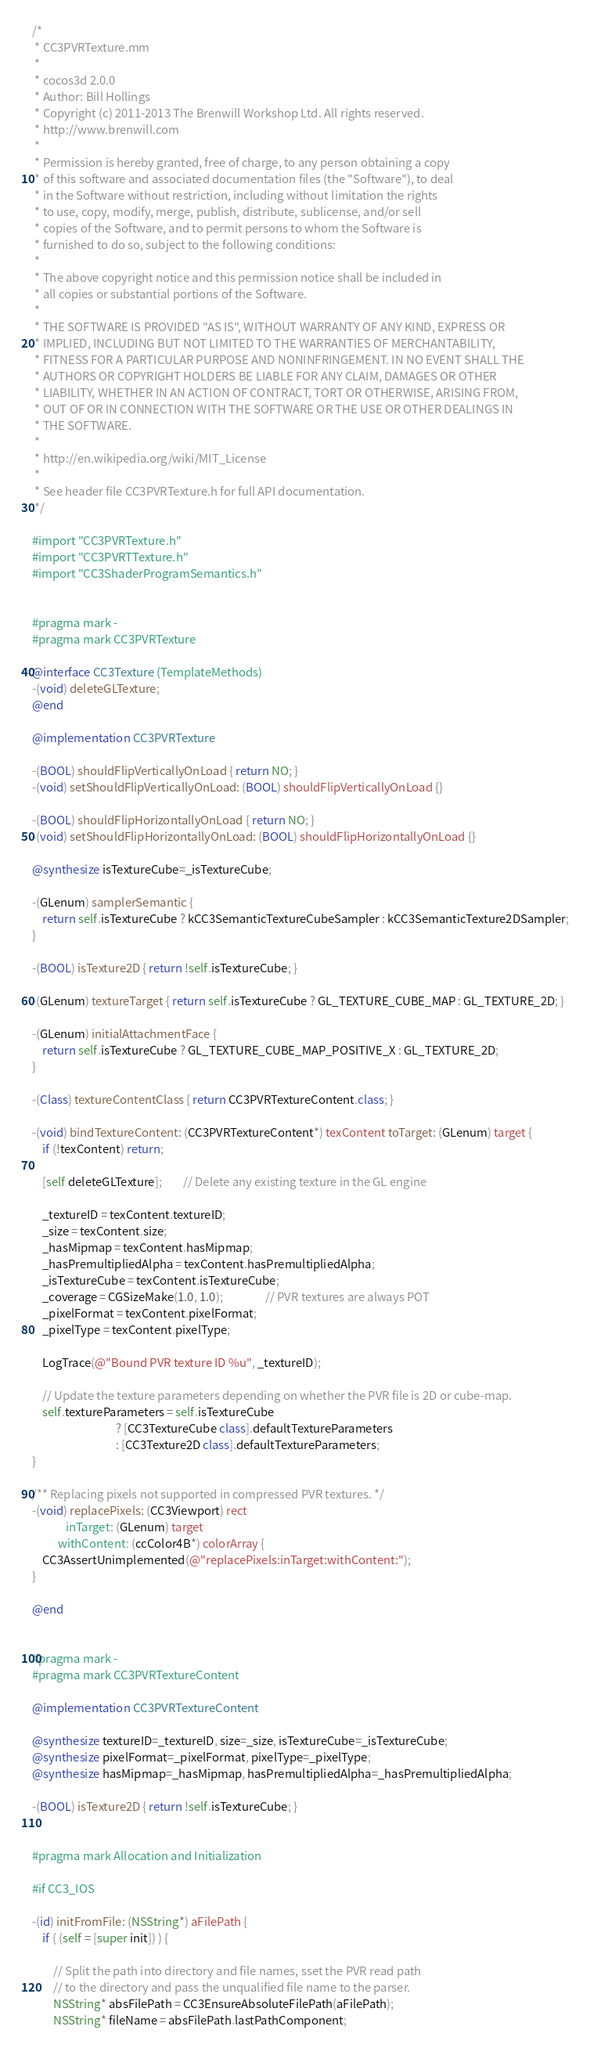Convert code to text. <code><loc_0><loc_0><loc_500><loc_500><_ObjectiveC_>/*
 * CC3PVRTexture.mm
 *
 * cocos3d 2.0.0
 * Author: Bill Hollings
 * Copyright (c) 2011-2013 The Brenwill Workshop Ltd. All rights reserved.
 * http://www.brenwill.com
 *
 * Permission is hereby granted, free of charge, to any person obtaining a copy
 * of this software and associated documentation files (the "Software"), to deal
 * in the Software without restriction, including without limitation the rights
 * to use, copy, modify, merge, publish, distribute, sublicense, and/or sell
 * copies of the Software, and to permit persons to whom the Software is
 * furnished to do so, subject to the following conditions:
 * 
 * The above copyright notice and this permission notice shall be included in
 * all copies or substantial portions of the Software.
 *
 * THE SOFTWARE IS PROVIDED "AS IS", WITHOUT WARRANTY OF ANY KIND, EXPRESS OR
 * IMPLIED, INCLUDING BUT NOT LIMITED TO THE WARRANTIES OF MERCHANTABILITY,
 * FITNESS FOR A PARTICULAR PURPOSE AND NONINFRINGEMENT. IN NO EVENT SHALL THE
 * AUTHORS OR COPYRIGHT HOLDERS BE LIABLE FOR ANY CLAIM, DAMAGES OR OTHER
 * LIABILITY, WHETHER IN AN ACTION OF CONTRACT, TORT OR OTHERWISE, ARISING FROM,
 * OUT OF OR IN CONNECTION WITH THE SOFTWARE OR THE USE OR OTHER DEALINGS IN
 * THE SOFTWARE.
 *
 * http://en.wikipedia.org/wiki/MIT_License
 * 
 * See header file CC3PVRTexture.h for full API documentation.
 */

#import "CC3PVRTexture.h"
#import "CC3PVRTTexture.h"
#import "CC3ShaderProgramSemantics.h"


#pragma mark -
#pragma mark CC3PVRTexture

@interface CC3Texture (TemplateMethods)
-(void) deleteGLTexture;
@end

@implementation CC3PVRTexture

-(BOOL) shouldFlipVerticallyOnLoad { return NO; }
-(void) setShouldFlipVerticallyOnLoad: (BOOL) shouldFlipVerticallyOnLoad {}

-(BOOL) shouldFlipHorizontallyOnLoad { return NO; }
-(void) setShouldFlipHorizontallyOnLoad: (BOOL) shouldFlipHorizontallyOnLoad {}

@synthesize isTextureCube=_isTextureCube;

-(GLenum) samplerSemantic {
	return self.isTextureCube ? kCC3SemanticTextureCubeSampler : kCC3SemanticTexture2DSampler;
}

-(BOOL) isTexture2D { return !self.isTextureCube; }

-(GLenum) textureTarget { return self.isTextureCube ? GL_TEXTURE_CUBE_MAP : GL_TEXTURE_2D; }

-(GLenum) initialAttachmentFace {
	return self.isTextureCube ? GL_TEXTURE_CUBE_MAP_POSITIVE_X : GL_TEXTURE_2D;
}

-(Class) textureContentClass { return CC3PVRTextureContent.class; }

-(void) bindTextureContent: (CC3PVRTextureContent*) texContent toTarget: (GLenum) target {
	if (!texContent) return;
	
	[self deleteGLTexture];		// Delete any existing texture in the GL engine
	
	_textureID = texContent.textureID;
	_size = texContent.size;
	_hasMipmap = texContent.hasMipmap;
	_hasPremultipliedAlpha = texContent.hasPremultipliedAlpha;
	_isTextureCube = texContent.isTextureCube;
	_coverage = CGSizeMake(1.0, 1.0);				// PVR textures are always POT
	_pixelFormat = texContent.pixelFormat;
	_pixelType = texContent.pixelType;
	
	LogTrace(@"Bound PVR texture ID %u", _textureID);
	
	// Update the texture parameters depending on whether the PVR file is 2D or cube-map.
	self.textureParameters = self.isTextureCube
								? [CC3TextureCube class].defaultTextureParameters
								: [CC3Texture2D class].defaultTextureParameters;
}

/** Replacing pixels not supported in compressed PVR textures. */
-(void) replacePixels: (CC3Viewport) rect
			 inTarget: (GLenum) target
		  withContent: (ccColor4B*) colorArray {
	CC3AssertUnimplemented(@"replacePixels:inTarget:withContent:");
}

@end


#pragma mark -
#pragma mark CC3PVRTextureContent

@implementation CC3PVRTextureContent

@synthesize textureID=_textureID, size=_size, isTextureCube=_isTextureCube;
@synthesize pixelFormat=_pixelFormat, pixelType=_pixelType;
@synthesize hasMipmap=_hasMipmap, hasPremultipliedAlpha=_hasPremultipliedAlpha;

-(BOOL) isTexture2D { return !self.isTextureCube; }


#pragma mark Allocation and Initialization

#if CC3_IOS

-(id) initFromFile: (NSString*) aFilePath {
	if ( (self = [super init]) ) {
		
		// Split the path into directory and file names, sset the PVR read path
		// to the directory and pass the unqualified file name to the parser.
		NSString* absFilePath = CC3EnsureAbsoluteFilePath(aFilePath);
		NSString* fileName = absFilePath.lastPathComponent;</code> 